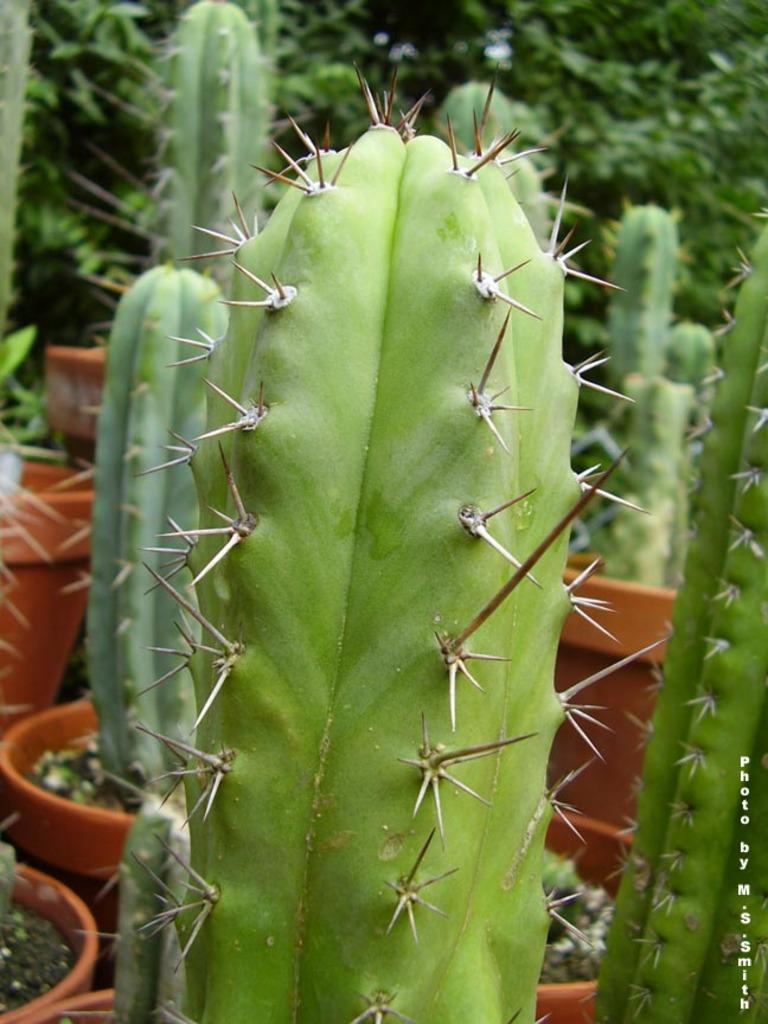What type of plants are in the image? There are cactus plants in the image. What type of pancake can be seen in the image? There is no pancake present in the image; it features cactus plants. How many cats are visible in the image? There are no cats visible in the image; it features cactus plants. 